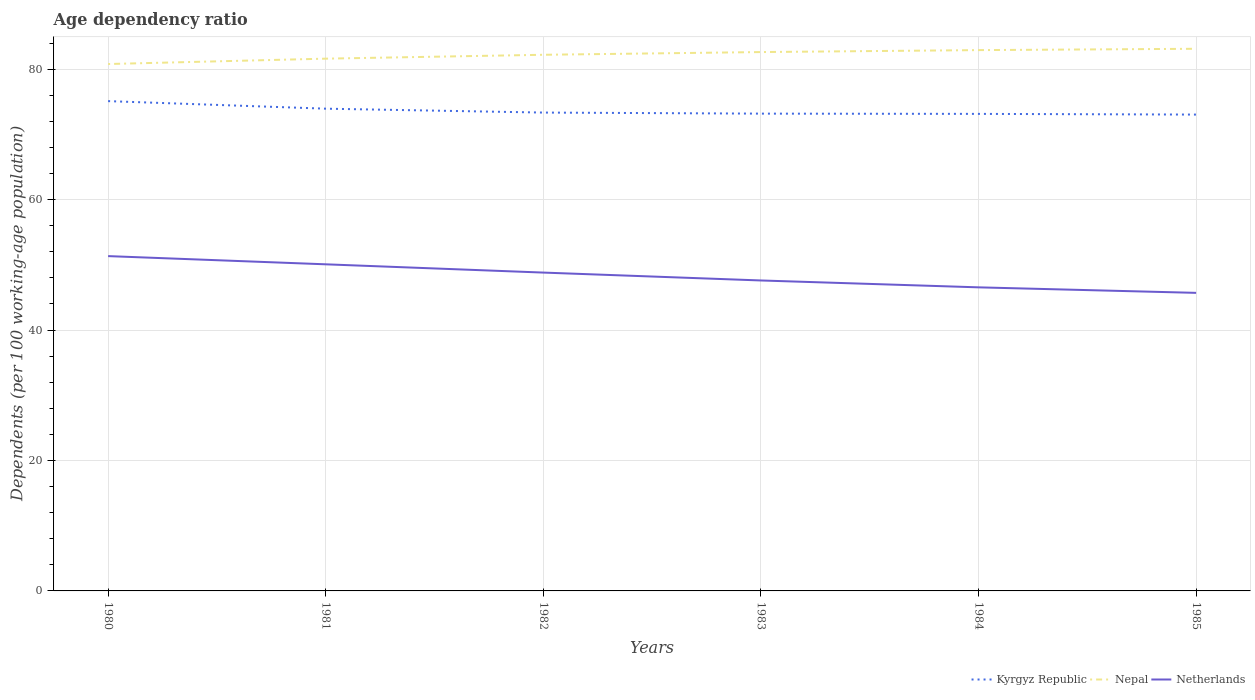Does the line corresponding to Netherlands intersect with the line corresponding to Kyrgyz Republic?
Give a very brief answer. No. Is the number of lines equal to the number of legend labels?
Your answer should be very brief. Yes. Across all years, what is the maximum age dependency ratio in in Netherlands?
Provide a short and direct response. 45.71. What is the total age dependency ratio in in Netherlands in the graph?
Your answer should be very brief. 4.79. What is the difference between the highest and the second highest age dependency ratio in in Nepal?
Ensure brevity in your answer.  2.34. What is the difference between the highest and the lowest age dependency ratio in in Kyrgyz Republic?
Make the answer very short. 2. Is the age dependency ratio in in Netherlands strictly greater than the age dependency ratio in in Kyrgyz Republic over the years?
Your response must be concise. Yes. How many lines are there?
Your answer should be very brief. 3. What is the difference between two consecutive major ticks on the Y-axis?
Offer a terse response. 20. Are the values on the major ticks of Y-axis written in scientific E-notation?
Provide a succinct answer. No. Where does the legend appear in the graph?
Offer a terse response. Bottom right. How many legend labels are there?
Offer a very short reply. 3. How are the legend labels stacked?
Offer a terse response. Horizontal. What is the title of the graph?
Your response must be concise. Age dependency ratio. What is the label or title of the Y-axis?
Offer a very short reply. Dependents (per 100 working-age population). What is the Dependents (per 100 working-age population) in Kyrgyz Republic in 1980?
Give a very brief answer. 75.11. What is the Dependents (per 100 working-age population) in Nepal in 1980?
Provide a short and direct response. 80.8. What is the Dependents (per 100 working-age population) of Netherlands in 1980?
Your answer should be compact. 51.34. What is the Dependents (per 100 working-age population) of Kyrgyz Republic in 1981?
Your answer should be compact. 73.95. What is the Dependents (per 100 working-age population) in Nepal in 1981?
Keep it short and to the point. 81.62. What is the Dependents (per 100 working-age population) of Netherlands in 1981?
Keep it short and to the point. 50.08. What is the Dependents (per 100 working-age population) in Kyrgyz Republic in 1982?
Offer a very short reply. 73.35. What is the Dependents (per 100 working-age population) of Nepal in 1982?
Your answer should be very brief. 82.21. What is the Dependents (per 100 working-age population) in Netherlands in 1982?
Provide a short and direct response. 48.82. What is the Dependents (per 100 working-age population) in Kyrgyz Republic in 1983?
Your answer should be compact. 73.19. What is the Dependents (per 100 working-age population) of Nepal in 1983?
Keep it short and to the point. 82.63. What is the Dependents (per 100 working-age population) in Netherlands in 1983?
Offer a terse response. 47.61. What is the Dependents (per 100 working-age population) in Kyrgyz Republic in 1984?
Provide a short and direct response. 73.15. What is the Dependents (per 100 working-age population) in Nepal in 1984?
Offer a very short reply. 82.93. What is the Dependents (per 100 working-age population) of Netherlands in 1984?
Your response must be concise. 46.55. What is the Dependents (per 100 working-age population) in Kyrgyz Republic in 1985?
Keep it short and to the point. 73.04. What is the Dependents (per 100 working-age population) of Nepal in 1985?
Your response must be concise. 83.14. What is the Dependents (per 100 working-age population) of Netherlands in 1985?
Offer a terse response. 45.71. Across all years, what is the maximum Dependents (per 100 working-age population) of Kyrgyz Republic?
Your answer should be compact. 75.11. Across all years, what is the maximum Dependents (per 100 working-age population) in Nepal?
Your answer should be compact. 83.14. Across all years, what is the maximum Dependents (per 100 working-age population) of Netherlands?
Your response must be concise. 51.34. Across all years, what is the minimum Dependents (per 100 working-age population) of Kyrgyz Republic?
Make the answer very short. 73.04. Across all years, what is the minimum Dependents (per 100 working-age population) in Nepal?
Keep it short and to the point. 80.8. Across all years, what is the minimum Dependents (per 100 working-age population) of Netherlands?
Make the answer very short. 45.71. What is the total Dependents (per 100 working-age population) in Kyrgyz Republic in the graph?
Offer a terse response. 441.8. What is the total Dependents (per 100 working-age population) in Nepal in the graph?
Ensure brevity in your answer.  493.33. What is the total Dependents (per 100 working-age population) in Netherlands in the graph?
Offer a very short reply. 290.11. What is the difference between the Dependents (per 100 working-age population) in Kyrgyz Republic in 1980 and that in 1981?
Your answer should be very brief. 1.16. What is the difference between the Dependents (per 100 working-age population) of Nepal in 1980 and that in 1981?
Your answer should be compact. -0.82. What is the difference between the Dependents (per 100 working-age population) in Netherlands in 1980 and that in 1981?
Offer a terse response. 1.26. What is the difference between the Dependents (per 100 working-age population) in Kyrgyz Republic in 1980 and that in 1982?
Keep it short and to the point. 1.76. What is the difference between the Dependents (per 100 working-age population) in Nepal in 1980 and that in 1982?
Offer a terse response. -1.42. What is the difference between the Dependents (per 100 working-age population) of Netherlands in 1980 and that in 1982?
Ensure brevity in your answer.  2.53. What is the difference between the Dependents (per 100 working-age population) in Kyrgyz Republic in 1980 and that in 1983?
Provide a succinct answer. 1.92. What is the difference between the Dependents (per 100 working-age population) of Nepal in 1980 and that in 1983?
Your answer should be compact. -1.84. What is the difference between the Dependents (per 100 working-age population) of Netherlands in 1980 and that in 1983?
Give a very brief answer. 3.73. What is the difference between the Dependents (per 100 working-age population) in Kyrgyz Republic in 1980 and that in 1984?
Keep it short and to the point. 1.96. What is the difference between the Dependents (per 100 working-age population) in Nepal in 1980 and that in 1984?
Keep it short and to the point. -2.13. What is the difference between the Dependents (per 100 working-age population) of Netherlands in 1980 and that in 1984?
Offer a terse response. 4.79. What is the difference between the Dependents (per 100 working-age population) in Kyrgyz Republic in 1980 and that in 1985?
Give a very brief answer. 2.06. What is the difference between the Dependents (per 100 working-age population) in Nepal in 1980 and that in 1985?
Your response must be concise. -2.34. What is the difference between the Dependents (per 100 working-age population) of Netherlands in 1980 and that in 1985?
Provide a short and direct response. 5.64. What is the difference between the Dependents (per 100 working-age population) in Kyrgyz Republic in 1981 and that in 1982?
Provide a succinct answer. 0.6. What is the difference between the Dependents (per 100 working-age population) in Nepal in 1981 and that in 1982?
Offer a very short reply. -0.59. What is the difference between the Dependents (per 100 working-age population) of Netherlands in 1981 and that in 1982?
Your answer should be very brief. 1.27. What is the difference between the Dependents (per 100 working-age population) in Kyrgyz Republic in 1981 and that in 1983?
Make the answer very short. 0.76. What is the difference between the Dependents (per 100 working-age population) in Nepal in 1981 and that in 1983?
Make the answer very short. -1.01. What is the difference between the Dependents (per 100 working-age population) in Netherlands in 1981 and that in 1983?
Ensure brevity in your answer.  2.48. What is the difference between the Dependents (per 100 working-age population) in Kyrgyz Republic in 1981 and that in 1984?
Provide a succinct answer. 0.8. What is the difference between the Dependents (per 100 working-age population) of Nepal in 1981 and that in 1984?
Your answer should be compact. -1.31. What is the difference between the Dependents (per 100 working-age population) of Netherlands in 1981 and that in 1984?
Provide a short and direct response. 3.53. What is the difference between the Dependents (per 100 working-age population) in Kyrgyz Republic in 1981 and that in 1985?
Provide a short and direct response. 0.9. What is the difference between the Dependents (per 100 working-age population) of Nepal in 1981 and that in 1985?
Offer a very short reply. -1.51. What is the difference between the Dependents (per 100 working-age population) in Netherlands in 1981 and that in 1985?
Provide a short and direct response. 4.38. What is the difference between the Dependents (per 100 working-age population) in Kyrgyz Republic in 1982 and that in 1983?
Your answer should be compact. 0.16. What is the difference between the Dependents (per 100 working-age population) in Nepal in 1982 and that in 1983?
Your response must be concise. -0.42. What is the difference between the Dependents (per 100 working-age population) of Netherlands in 1982 and that in 1983?
Your answer should be very brief. 1.21. What is the difference between the Dependents (per 100 working-age population) of Kyrgyz Republic in 1982 and that in 1984?
Make the answer very short. 0.2. What is the difference between the Dependents (per 100 working-age population) of Nepal in 1982 and that in 1984?
Offer a terse response. -0.72. What is the difference between the Dependents (per 100 working-age population) of Netherlands in 1982 and that in 1984?
Offer a terse response. 2.27. What is the difference between the Dependents (per 100 working-age population) of Kyrgyz Republic in 1982 and that in 1985?
Your answer should be very brief. 0.31. What is the difference between the Dependents (per 100 working-age population) in Nepal in 1982 and that in 1985?
Make the answer very short. -0.92. What is the difference between the Dependents (per 100 working-age population) of Netherlands in 1982 and that in 1985?
Offer a terse response. 3.11. What is the difference between the Dependents (per 100 working-age population) of Kyrgyz Republic in 1983 and that in 1984?
Offer a very short reply. 0.04. What is the difference between the Dependents (per 100 working-age population) in Nepal in 1983 and that in 1984?
Your response must be concise. -0.3. What is the difference between the Dependents (per 100 working-age population) in Netherlands in 1983 and that in 1984?
Your response must be concise. 1.06. What is the difference between the Dependents (per 100 working-age population) of Kyrgyz Republic in 1983 and that in 1985?
Offer a terse response. 0.15. What is the difference between the Dependents (per 100 working-age population) in Nepal in 1983 and that in 1985?
Provide a succinct answer. -0.5. What is the difference between the Dependents (per 100 working-age population) in Netherlands in 1983 and that in 1985?
Your answer should be compact. 1.9. What is the difference between the Dependents (per 100 working-age population) in Kyrgyz Republic in 1984 and that in 1985?
Offer a very short reply. 0.11. What is the difference between the Dependents (per 100 working-age population) in Nepal in 1984 and that in 1985?
Your answer should be compact. -0.2. What is the difference between the Dependents (per 100 working-age population) in Netherlands in 1984 and that in 1985?
Make the answer very short. 0.85. What is the difference between the Dependents (per 100 working-age population) of Kyrgyz Republic in 1980 and the Dependents (per 100 working-age population) of Nepal in 1981?
Keep it short and to the point. -6.51. What is the difference between the Dependents (per 100 working-age population) in Kyrgyz Republic in 1980 and the Dependents (per 100 working-age population) in Netherlands in 1981?
Offer a terse response. 25.02. What is the difference between the Dependents (per 100 working-age population) in Nepal in 1980 and the Dependents (per 100 working-age population) in Netherlands in 1981?
Provide a short and direct response. 30.71. What is the difference between the Dependents (per 100 working-age population) in Kyrgyz Republic in 1980 and the Dependents (per 100 working-age population) in Nepal in 1982?
Offer a terse response. -7.11. What is the difference between the Dependents (per 100 working-age population) of Kyrgyz Republic in 1980 and the Dependents (per 100 working-age population) of Netherlands in 1982?
Provide a succinct answer. 26.29. What is the difference between the Dependents (per 100 working-age population) in Nepal in 1980 and the Dependents (per 100 working-age population) in Netherlands in 1982?
Give a very brief answer. 31.98. What is the difference between the Dependents (per 100 working-age population) in Kyrgyz Republic in 1980 and the Dependents (per 100 working-age population) in Nepal in 1983?
Ensure brevity in your answer.  -7.52. What is the difference between the Dependents (per 100 working-age population) in Kyrgyz Republic in 1980 and the Dependents (per 100 working-age population) in Netherlands in 1983?
Ensure brevity in your answer.  27.5. What is the difference between the Dependents (per 100 working-age population) in Nepal in 1980 and the Dependents (per 100 working-age population) in Netherlands in 1983?
Offer a very short reply. 33.19. What is the difference between the Dependents (per 100 working-age population) of Kyrgyz Republic in 1980 and the Dependents (per 100 working-age population) of Nepal in 1984?
Your response must be concise. -7.82. What is the difference between the Dependents (per 100 working-age population) of Kyrgyz Republic in 1980 and the Dependents (per 100 working-age population) of Netherlands in 1984?
Your response must be concise. 28.56. What is the difference between the Dependents (per 100 working-age population) in Nepal in 1980 and the Dependents (per 100 working-age population) in Netherlands in 1984?
Offer a terse response. 34.24. What is the difference between the Dependents (per 100 working-age population) in Kyrgyz Republic in 1980 and the Dependents (per 100 working-age population) in Nepal in 1985?
Keep it short and to the point. -8.03. What is the difference between the Dependents (per 100 working-age population) in Kyrgyz Republic in 1980 and the Dependents (per 100 working-age population) in Netherlands in 1985?
Your answer should be compact. 29.4. What is the difference between the Dependents (per 100 working-age population) in Nepal in 1980 and the Dependents (per 100 working-age population) in Netherlands in 1985?
Ensure brevity in your answer.  35.09. What is the difference between the Dependents (per 100 working-age population) of Kyrgyz Republic in 1981 and the Dependents (per 100 working-age population) of Nepal in 1982?
Offer a terse response. -8.27. What is the difference between the Dependents (per 100 working-age population) of Kyrgyz Republic in 1981 and the Dependents (per 100 working-age population) of Netherlands in 1982?
Keep it short and to the point. 25.13. What is the difference between the Dependents (per 100 working-age population) in Nepal in 1981 and the Dependents (per 100 working-age population) in Netherlands in 1982?
Make the answer very short. 32.8. What is the difference between the Dependents (per 100 working-age population) of Kyrgyz Republic in 1981 and the Dependents (per 100 working-age population) of Nepal in 1983?
Provide a succinct answer. -8.68. What is the difference between the Dependents (per 100 working-age population) in Kyrgyz Republic in 1981 and the Dependents (per 100 working-age population) in Netherlands in 1983?
Your answer should be compact. 26.34. What is the difference between the Dependents (per 100 working-age population) in Nepal in 1981 and the Dependents (per 100 working-age population) in Netherlands in 1983?
Keep it short and to the point. 34.01. What is the difference between the Dependents (per 100 working-age population) in Kyrgyz Republic in 1981 and the Dependents (per 100 working-age population) in Nepal in 1984?
Make the answer very short. -8.98. What is the difference between the Dependents (per 100 working-age population) in Kyrgyz Republic in 1981 and the Dependents (per 100 working-age population) in Netherlands in 1984?
Give a very brief answer. 27.4. What is the difference between the Dependents (per 100 working-age population) of Nepal in 1981 and the Dependents (per 100 working-age population) of Netherlands in 1984?
Ensure brevity in your answer.  35.07. What is the difference between the Dependents (per 100 working-age population) in Kyrgyz Republic in 1981 and the Dependents (per 100 working-age population) in Nepal in 1985?
Make the answer very short. -9.19. What is the difference between the Dependents (per 100 working-age population) in Kyrgyz Republic in 1981 and the Dependents (per 100 working-age population) in Netherlands in 1985?
Make the answer very short. 28.24. What is the difference between the Dependents (per 100 working-age population) of Nepal in 1981 and the Dependents (per 100 working-age population) of Netherlands in 1985?
Give a very brief answer. 35.91. What is the difference between the Dependents (per 100 working-age population) of Kyrgyz Republic in 1982 and the Dependents (per 100 working-age population) of Nepal in 1983?
Your answer should be compact. -9.28. What is the difference between the Dependents (per 100 working-age population) in Kyrgyz Republic in 1982 and the Dependents (per 100 working-age population) in Netherlands in 1983?
Ensure brevity in your answer.  25.75. What is the difference between the Dependents (per 100 working-age population) in Nepal in 1982 and the Dependents (per 100 working-age population) in Netherlands in 1983?
Ensure brevity in your answer.  34.61. What is the difference between the Dependents (per 100 working-age population) in Kyrgyz Republic in 1982 and the Dependents (per 100 working-age population) in Nepal in 1984?
Provide a succinct answer. -9.58. What is the difference between the Dependents (per 100 working-age population) in Kyrgyz Republic in 1982 and the Dependents (per 100 working-age population) in Netherlands in 1984?
Your answer should be compact. 26.8. What is the difference between the Dependents (per 100 working-age population) in Nepal in 1982 and the Dependents (per 100 working-age population) in Netherlands in 1984?
Ensure brevity in your answer.  35.66. What is the difference between the Dependents (per 100 working-age population) of Kyrgyz Republic in 1982 and the Dependents (per 100 working-age population) of Nepal in 1985?
Your answer should be very brief. -9.78. What is the difference between the Dependents (per 100 working-age population) of Kyrgyz Republic in 1982 and the Dependents (per 100 working-age population) of Netherlands in 1985?
Make the answer very short. 27.65. What is the difference between the Dependents (per 100 working-age population) of Nepal in 1982 and the Dependents (per 100 working-age population) of Netherlands in 1985?
Give a very brief answer. 36.51. What is the difference between the Dependents (per 100 working-age population) in Kyrgyz Republic in 1983 and the Dependents (per 100 working-age population) in Nepal in 1984?
Provide a short and direct response. -9.74. What is the difference between the Dependents (per 100 working-age population) of Kyrgyz Republic in 1983 and the Dependents (per 100 working-age population) of Netherlands in 1984?
Provide a succinct answer. 26.64. What is the difference between the Dependents (per 100 working-age population) in Nepal in 1983 and the Dependents (per 100 working-age population) in Netherlands in 1984?
Keep it short and to the point. 36.08. What is the difference between the Dependents (per 100 working-age population) of Kyrgyz Republic in 1983 and the Dependents (per 100 working-age population) of Nepal in 1985?
Provide a succinct answer. -9.94. What is the difference between the Dependents (per 100 working-age population) of Kyrgyz Republic in 1983 and the Dependents (per 100 working-age population) of Netherlands in 1985?
Your response must be concise. 27.48. What is the difference between the Dependents (per 100 working-age population) of Nepal in 1983 and the Dependents (per 100 working-age population) of Netherlands in 1985?
Offer a terse response. 36.93. What is the difference between the Dependents (per 100 working-age population) of Kyrgyz Republic in 1984 and the Dependents (per 100 working-age population) of Nepal in 1985?
Your answer should be very brief. -9.98. What is the difference between the Dependents (per 100 working-age population) in Kyrgyz Republic in 1984 and the Dependents (per 100 working-age population) in Netherlands in 1985?
Your response must be concise. 27.45. What is the difference between the Dependents (per 100 working-age population) in Nepal in 1984 and the Dependents (per 100 working-age population) in Netherlands in 1985?
Your answer should be compact. 37.22. What is the average Dependents (per 100 working-age population) of Kyrgyz Republic per year?
Make the answer very short. 73.63. What is the average Dependents (per 100 working-age population) of Nepal per year?
Your answer should be compact. 82.22. What is the average Dependents (per 100 working-age population) in Netherlands per year?
Give a very brief answer. 48.35. In the year 1980, what is the difference between the Dependents (per 100 working-age population) of Kyrgyz Republic and Dependents (per 100 working-age population) of Nepal?
Offer a terse response. -5.69. In the year 1980, what is the difference between the Dependents (per 100 working-age population) of Kyrgyz Republic and Dependents (per 100 working-age population) of Netherlands?
Make the answer very short. 23.77. In the year 1980, what is the difference between the Dependents (per 100 working-age population) of Nepal and Dependents (per 100 working-age population) of Netherlands?
Provide a short and direct response. 29.45. In the year 1981, what is the difference between the Dependents (per 100 working-age population) of Kyrgyz Republic and Dependents (per 100 working-age population) of Nepal?
Make the answer very short. -7.67. In the year 1981, what is the difference between the Dependents (per 100 working-age population) in Kyrgyz Republic and Dependents (per 100 working-age population) in Netherlands?
Your answer should be very brief. 23.87. In the year 1981, what is the difference between the Dependents (per 100 working-age population) in Nepal and Dependents (per 100 working-age population) in Netherlands?
Offer a very short reply. 31.54. In the year 1982, what is the difference between the Dependents (per 100 working-age population) in Kyrgyz Republic and Dependents (per 100 working-age population) in Nepal?
Provide a succinct answer. -8.86. In the year 1982, what is the difference between the Dependents (per 100 working-age population) of Kyrgyz Republic and Dependents (per 100 working-age population) of Netherlands?
Offer a very short reply. 24.54. In the year 1982, what is the difference between the Dependents (per 100 working-age population) in Nepal and Dependents (per 100 working-age population) in Netherlands?
Provide a short and direct response. 33.4. In the year 1983, what is the difference between the Dependents (per 100 working-age population) in Kyrgyz Republic and Dependents (per 100 working-age population) in Nepal?
Make the answer very short. -9.44. In the year 1983, what is the difference between the Dependents (per 100 working-age population) of Kyrgyz Republic and Dependents (per 100 working-age population) of Netherlands?
Keep it short and to the point. 25.58. In the year 1983, what is the difference between the Dependents (per 100 working-age population) of Nepal and Dependents (per 100 working-age population) of Netherlands?
Your response must be concise. 35.02. In the year 1984, what is the difference between the Dependents (per 100 working-age population) of Kyrgyz Republic and Dependents (per 100 working-age population) of Nepal?
Make the answer very short. -9.78. In the year 1984, what is the difference between the Dependents (per 100 working-age population) in Kyrgyz Republic and Dependents (per 100 working-age population) in Netherlands?
Provide a succinct answer. 26.6. In the year 1984, what is the difference between the Dependents (per 100 working-age population) of Nepal and Dependents (per 100 working-age population) of Netherlands?
Your answer should be very brief. 36.38. In the year 1985, what is the difference between the Dependents (per 100 working-age population) in Kyrgyz Republic and Dependents (per 100 working-age population) in Nepal?
Offer a terse response. -10.09. In the year 1985, what is the difference between the Dependents (per 100 working-age population) in Kyrgyz Republic and Dependents (per 100 working-age population) in Netherlands?
Make the answer very short. 27.34. In the year 1985, what is the difference between the Dependents (per 100 working-age population) in Nepal and Dependents (per 100 working-age population) in Netherlands?
Offer a terse response. 37.43. What is the ratio of the Dependents (per 100 working-age population) in Kyrgyz Republic in 1980 to that in 1981?
Keep it short and to the point. 1.02. What is the ratio of the Dependents (per 100 working-age population) of Netherlands in 1980 to that in 1981?
Your answer should be very brief. 1.03. What is the ratio of the Dependents (per 100 working-age population) in Kyrgyz Republic in 1980 to that in 1982?
Keep it short and to the point. 1.02. What is the ratio of the Dependents (per 100 working-age population) in Nepal in 1980 to that in 1982?
Your answer should be very brief. 0.98. What is the ratio of the Dependents (per 100 working-age population) in Netherlands in 1980 to that in 1982?
Offer a terse response. 1.05. What is the ratio of the Dependents (per 100 working-age population) in Kyrgyz Republic in 1980 to that in 1983?
Offer a very short reply. 1.03. What is the ratio of the Dependents (per 100 working-age population) of Nepal in 1980 to that in 1983?
Ensure brevity in your answer.  0.98. What is the ratio of the Dependents (per 100 working-age population) in Netherlands in 1980 to that in 1983?
Offer a very short reply. 1.08. What is the ratio of the Dependents (per 100 working-age population) of Kyrgyz Republic in 1980 to that in 1984?
Give a very brief answer. 1.03. What is the ratio of the Dependents (per 100 working-age population) in Nepal in 1980 to that in 1984?
Your answer should be very brief. 0.97. What is the ratio of the Dependents (per 100 working-age population) in Netherlands in 1980 to that in 1984?
Your response must be concise. 1.1. What is the ratio of the Dependents (per 100 working-age population) in Kyrgyz Republic in 1980 to that in 1985?
Provide a succinct answer. 1.03. What is the ratio of the Dependents (per 100 working-age population) in Nepal in 1980 to that in 1985?
Offer a very short reply. 0.97. What is the ratio of the Dependents (per 100 working-age population) of Netherlands in 1980 to that in 1985?
Keep it short and to the point. 1.12. What is the ratio of the Dependents (per 100 working-age population) of Nepal in 1981 to that in 1982?
Your answer should be very brief. 0.99. What is the ratio of the Dependents (per 100 working-age population) of Kyrgyz Republic in 1981 to that in 1983?
Make the answer very short. 1.01. What is the ratio of the Dependents (per 100 working-age population) of Netherlands in 1981 to that in 1983?
Provide a short and direct response. 1.05. What is the ratio of the Dependents (per 100 working-age population) in Kyrgyz Republic in 1981 to that in 1984?
Offer a very short reply. 1.01. What is the ratio of the Dependents (per 100 working-age population) in Nepal in 1981 to that in 1984?
Ensure brevity in your answer.  0.98. What is the ratio of the Dependents (per 100 working-age population) in Netherlands in 1981 to that in 1984?
Make the answer very short. 1.08. What is the ratio of the Dependents (per 100 working-age population) of Kyrgyz Republic in 1981 to that in 1985?
Make the answer very short. 1.01. What is the ratio of the Dependents (per 100 working-age population) of Nepal in 1981 to that in 1985?
Your answer should be very brief. 0.98. What is the ratio of the Dependents (per 100 working-age population) in Netherlands in 1981 to that in 1985?
Offer a very short reply. 1.1. What is the ratio of the Dependents (per 100 working-age population) in Netherlands in 1982 to that in 1983?
Keep it short and to the point. 1.03. What is the ratio of the Dependents (per 100 working-age population) in Kyrgyz Republic in 1982 to that in 1984?
Your answer should be compact. 1. What is the ratio of the Dependents (per 100 working-age population) in Nepal in 1982 to that in 1984?
Your answer should be very brief. 0.99. What is the ratio of the Dependents (per 100 working-age population) in Netherlands in 1982 to that in 1984?
Your answer should be compact. 1.05. What is the ratio of the Dependents (per 100 working-age population) in Nepal in 1982 to that in 1985?
Offer a very short reply. 0.99. What is the ratio of the Dependents (per 100 working-age population) of Netherlands in 1982 to that in 1985?
Provide a short and direct response. 1.07. What is the ratio of the Dependents (per 100 working-age population) in Nepal in 1983 to that in 1984?
Ensure brevity in your answer.  1. What is the ratio of the Dependents (per 100 working-age population) of Netherlands in 1983 to that in 1984?
Provide a short and direct response. 1.02. What is the ratio of the Dependents (per 100 working-age population) of Nepal in 1983 to that in 1985?
Keep it short and to the point. 0.99. What is the ratio of the Dependents (per 100 working-age population) in Netherlands in 1983 to that in 1985?
Your answer should be compact. 1.04. What is the ratio of the Dependents (per 100 working-age population) of Kyrgyz Republic in 1984 to that in 1985?
Ensure brevity in your answer.  1. What is the ratio of the Dependents (per 100 working-age population) in Netherlands in 1984 to that in 1985?
Offer a very short reply. 1.02. What is the difference between the highest and the second highest Dependents (per 100 working-age population) in Kyrgyz Republic?
Your answer should be compact. 1.16. What is the difference between the highest and the second highest Dependents (per 100 working-age population) of Nepal?
Keep it short and to the point. 0.2. What is the difference between the highest and the second highest Dependents (per 100 working-age population) of Netherlands?
Offer a very short reply. 1.26. What is the difference between the highest and the lowest Dependents (per 100 working-age population) in Kyrgyz Republic?
Give a very brief answer. 2.06. What is the difference between the highest and the lowest Dependents (per 100 working-age population) of Nepal?
Offer a very short reply. 2.34. What is the difference between the highest and the lowest Dependents (per 100 working-age population) in Netherlands?
Offer a very short reply. 5.64. 